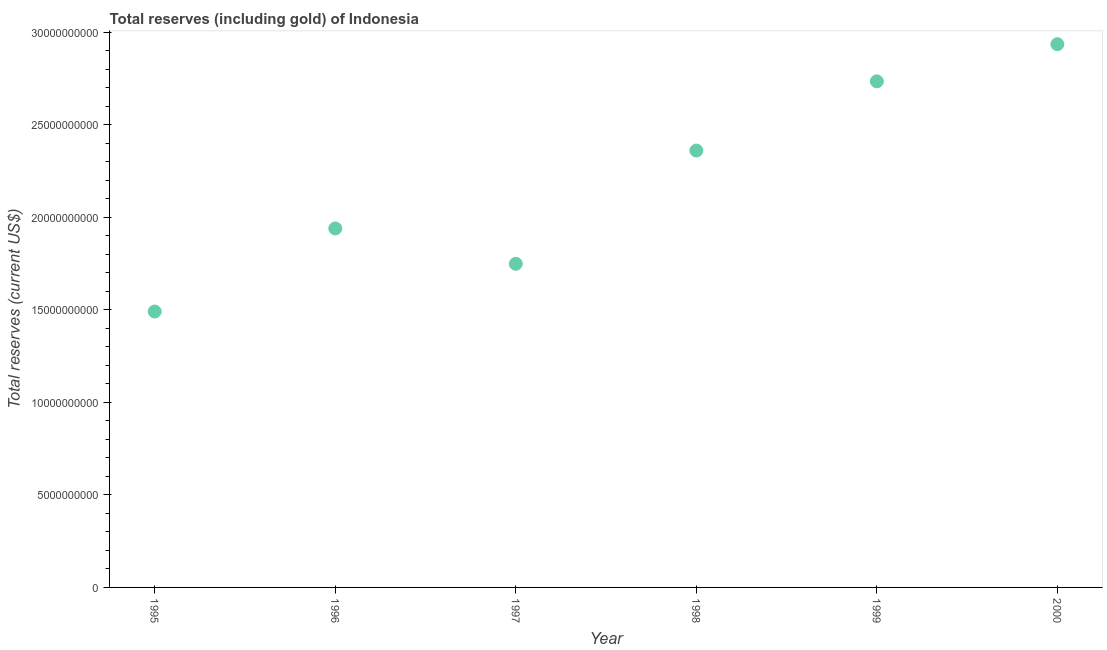What is the total reserves (including gold) in 1995?
Keep it short and to the point. 1.49e+1. Across all years, what is the maximum total reserves (including gold)?
Give a very brief answer. 2.94e+1. Across all years, what is the minimum total reserves (including gold)?
Offer a terse response. 1.49e+1. In which year was the total reserves (including gold) maximum?
Offer a terse response. 2000. In which year was the total reserves (including gold) minimum?
Your answer should be compact. 1995. What is the sum of the total reserves (including gold)?
Your answer should be compact. 1.32e+11. What is the difference between the total reserves (including gold) in 1997 and 1999?
Your response must be concise. -9.86e+09. What is the average total reserves (including gold) per year?
Provide a succinct answer. 2.20e+1. What is the median total reserves (including gold)?
Keep it short and to the point. 2.15e+1. What is the ratio of the total reserves (including gold) in 1997 to that in 2000?
Make the answer very short. 0.6. Is the difference between the total reserves (including gold) in 1995 and 1999 greater than the difference between any two years?
Your answer should be very brief. No. What is the difference between the highest and the second highest total reserves (including gold)?
Your answer should be compact. 2.01e+09. Is the sum of the total reserves (including gold) in 1998 and 1999 greater than the maximum total reserves (including gold) across all years?
Keep it short and to the point. Yes. What is the difference between the highest and the lowest total reserves (including gold)?
Provide a succinct answer. 1.44e+1. Does the graph contain any zero values?
Your response must be concise. No. Does the graph contain grids?
Give a very brief answer. No. What is the title of the graph?
Your answer should be compact. Total reserves (including gold) of Indonesia. What is the label or title of the X-axis?
Make the answer very short. Year. What is the label or title of the Y-axis?
Offer a very short reply. Total reserves (current US$). What is the Total reserves (current US$) in 1995?
Provide a succinct answer. 1.49e+1. What is the Total reserves (current US$) in 1996?
Your answer should be very brief. 1.94e+1. What is the Total reserves (current US$) in 1997?
Offer a terse response. 1.75e+1. What is the Total reserves (current US$) in 1998?
Your response must be concise. 2.36e+1. What is the Total reserves (current US$) in 1999?
Keep it short and to the point. 2.73e+1. What is the Total reserves (current US$) in 2000?
Your response must be concise. 2.94e+1. What is the difference between the Total reserves (current US$) in 1995 and 1996?
Your answer should be compact. -4.49e+09. What is the difference between the Total reserves (current US$) in 1995 and 1997?
Provide a short and direct response. -2.58e+09. What is the difference between the Total reserves (current US$) in 1995 and 1998?
Give a very brief answer. -8.70e+09. What is the difference between the Total reserves (current US$) in 1995 and 1999?
Ensure brevity in your answer.  -1.24e+1. What is the difference between the Total reserves (current US$) in 1995 and 2000?
Provide a short and direct response. -1.44e+1. What is the difference between the Total reserves (current US$) in 1996 and 1997?
Offer a very short reply. 1.91e+09. What is the difference between the Total reserves (current US$) in 1996 and 1998?
Make the answer very short. -4.21e+09. What is the difference between the Total reserves (current US$) in 1996 and 1999?
Provide a short and direct response. -7.95e+09. What is the difference between the Total reserves (current US$) in 1996 and 2000?
Provide a succinct answer. -9.96e+09. What is the difference between the Total reserves (current US$) in 1997 and 1998?
Give a very brief answer. -6.12e+09. What is the difference between the Total reserves (current US$) in 1997 and 1999?
Keep it short and to the point. -9.86e+09. What is the difference between the Total reserves (current US$) in 1997 and 2000?
Your response must be concise. -1.19e+1. What is the difference between the Total reserves (current US$) in 1998 and 1999?
Offer a terse response. -3.74e+09. What is the difference between the Total reserves (current US$) in 1998 and 2000?
Your answer should be compact. -5.75e+09. What is the difference between the Total reserves (current US$) in 1999 and 2000?
Your answer should be very brief. -2.01e+09. What is the ratio of the Total reserves (current US$) in 1995 to that in 1996?
Provide a succinct answer. 0.77. What is the ratio of the Total reserves (current US$) in 1995 to that in 1997?
Offer a very short reply. 0.85. What is the ratio of the Total reserves (current US$) in 1995 to that in 1998?
Offer a very short reply. 0.63. What is the ratio of the Total reserves (current US$) in 1995 to that in 1999?
Ensure brevity in your answer.  0.55. What is the ratio of the Total reserves (current US$) in 1995 to that in 2000?
Provide a short and direct response. 0.51. What is the ratio of the Total reserves (current US$) in 1996 to that in 1997?
Give a very brief answer. 1.11. What is the ratio of the Total reserves (current US$) in 1996 to that in 1998?
Your answer should be compact. 0.82. What is the ratio of the Total reserves (current US$) in 1996 to that in 1999?
Offer a very short reply. 0.71. What is the ratio of the Total reserves (current US$) in 1996 to that in 2000?
Provide a short and direct response. 0.66. What is the ratio of the Total reserves (current US$) in 1997 to that in 1998?
Provide a succinct answer. 0.74. What is the ratio of the Total reserves (current US$) in 1997 to that in 1999?
Give a very brief answer. 0.64. What is the ratio of the Total reserves (current US$) in 1997 to that in 2000?
Give a very brief answer. 0.6. What is the ratio of the Total reserves (current US$) in 1998 to that in 1999?
Provide a succinct answer. 0.86. What is the ratio of the Total reserves (current US$) in 1998 to that in 2000?
Provide a succinct answer. 0.8. What is the ratio of the Total reserves (current US$) in 1999 to that in 2000?
Make the answer very short. 0.93. 